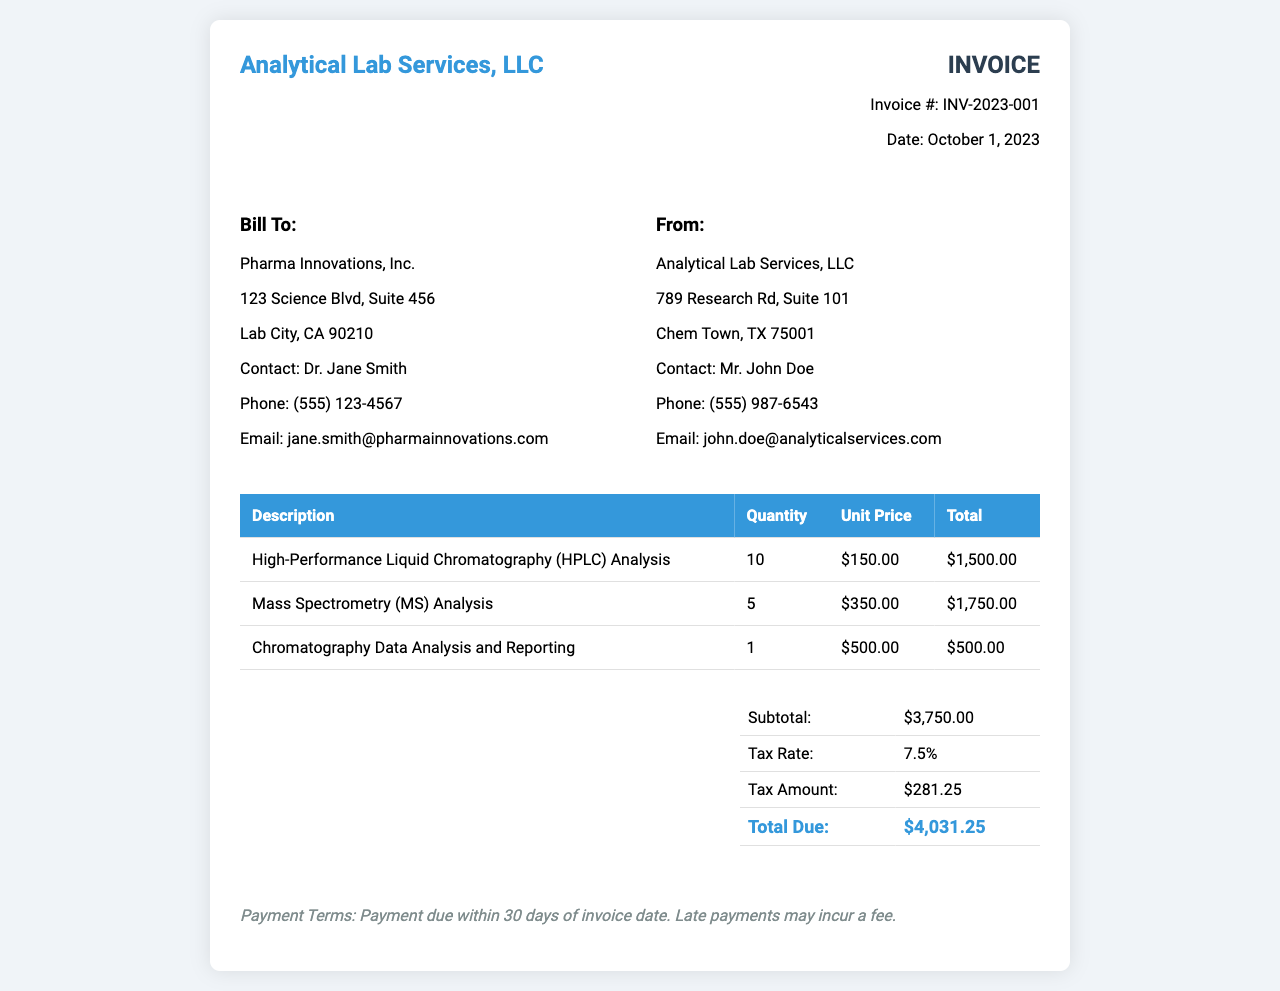What is the invoice number? The invoice number can be found in the invoice details section, which lists it as INV-2023-001.
Answer: INV-2023-001 Who is the contact person for the billing company? The contact person for Pharma Innovations, Inc. is mentioned as Dr. Jane Smith.
Answer: Dr. Jane Smith What is the date of the invoice? The date of the invoice is specified in the invoice details, which states October 1, 2023.
Answer: October 1, 2023 How many High-Performance Liquid Chromatography (HPLC) analyses were performed? The quantity of HPLC analyses is listed in the services table, which indicates 10 analyses.
Answer: 10 What is the subtotal amount before tax? The subtotal before tax is detailed in the summary table, showing a subtotal of $3,750.00.
Answer: $3,750.00 What is the tax rate applied to this invoice? The tax rate is mentioned in the summary table as 7.5%.
Answer: 7.5% How much is the tax amount? The tax amount is provided in the summary table, indicating a tax amount of $281.25.
Answer: $281.25 What is the total due amount? The total due is the final amount calculated in the summary table, which is shown as $4,031.25.
Answer: $4,031.25 What is the payment term stated in the invoice? The payment terms are mentioned at the bottom of the invoice, stating payment is due within 30 days.
Answer: 30 days 